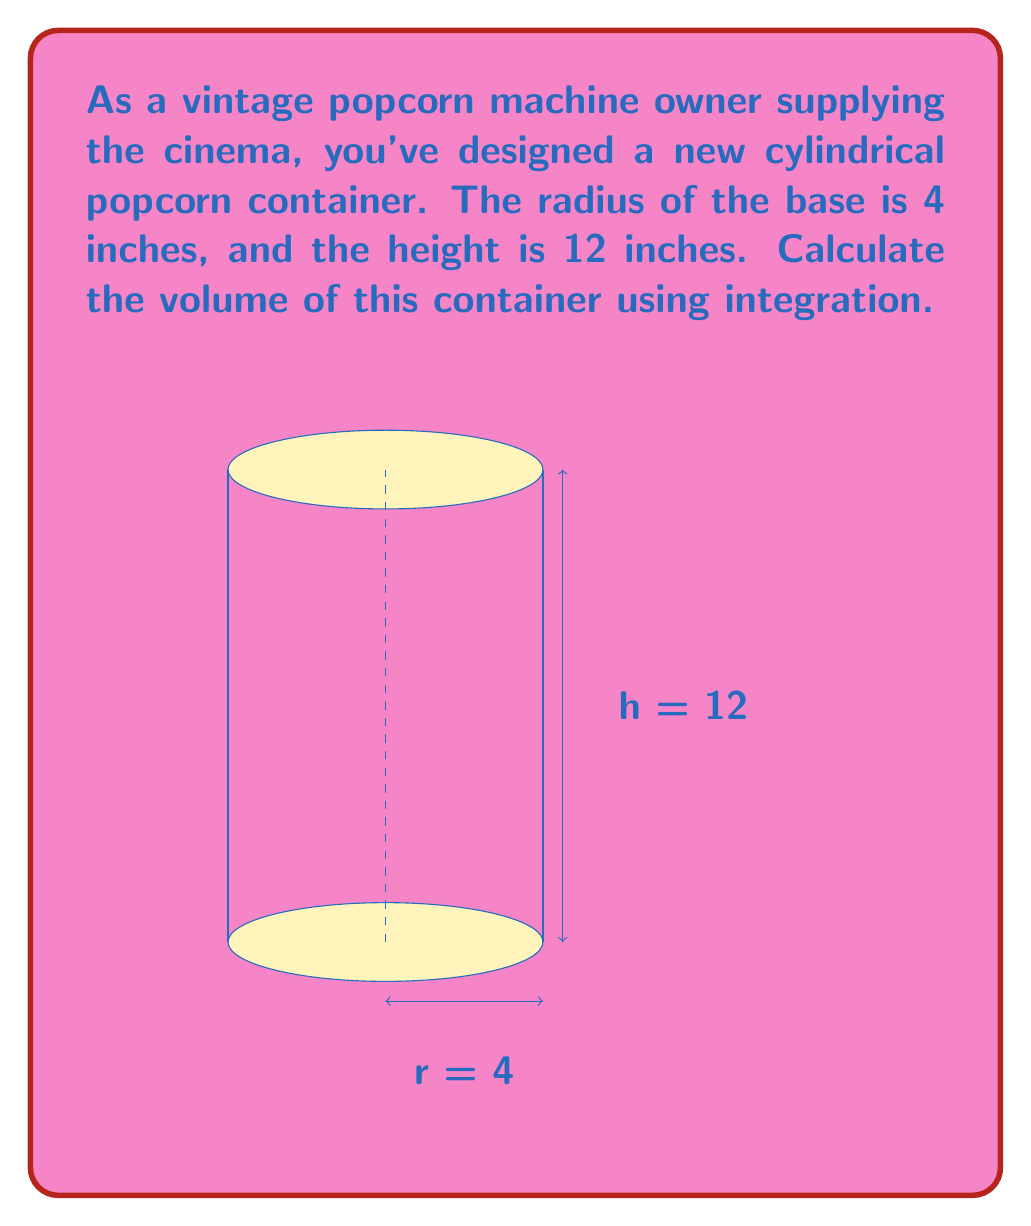Help me with this question. To calculate the volume of a cylindrical container using integration, we'll follow these steps:

1) The volume of a cylinder can be thought of as the sum of infinitely thin circular disks stacked on top of each other.

2) The area of each circular disk is given by $A = \pi r^2$, where $r$ is the radius.

3) In this case, the radius is constant at 4 inches throughout the height of the cylinder.

4) We can set up an integral to sum these areas over the height of the cylinder:

   $$V = \int_0^h \pi r^2 \, dz$$

   where $h$ is the height of the cylinder.

5) Since $r$ is constant, we can take $\pi r^2$ out of the integral:

   $$V = \pi r^2 \int_0^h \, dz$$

6) Evaluating the integral:

   $$V = \pi r^2 [z]_0^h = \pi r^2 h$$

7) Now we can substitute the values:
   $r = 4$ inches
   $h = 12$ inches

   $$V = \pi (4^2) (12) = 16\pi (12) = 192\pi$$

8) Therefore, the volume of the cylindrical popcorn container is $192\pi$ cubic inches.
Answer: $192\pi$ cubic inches 